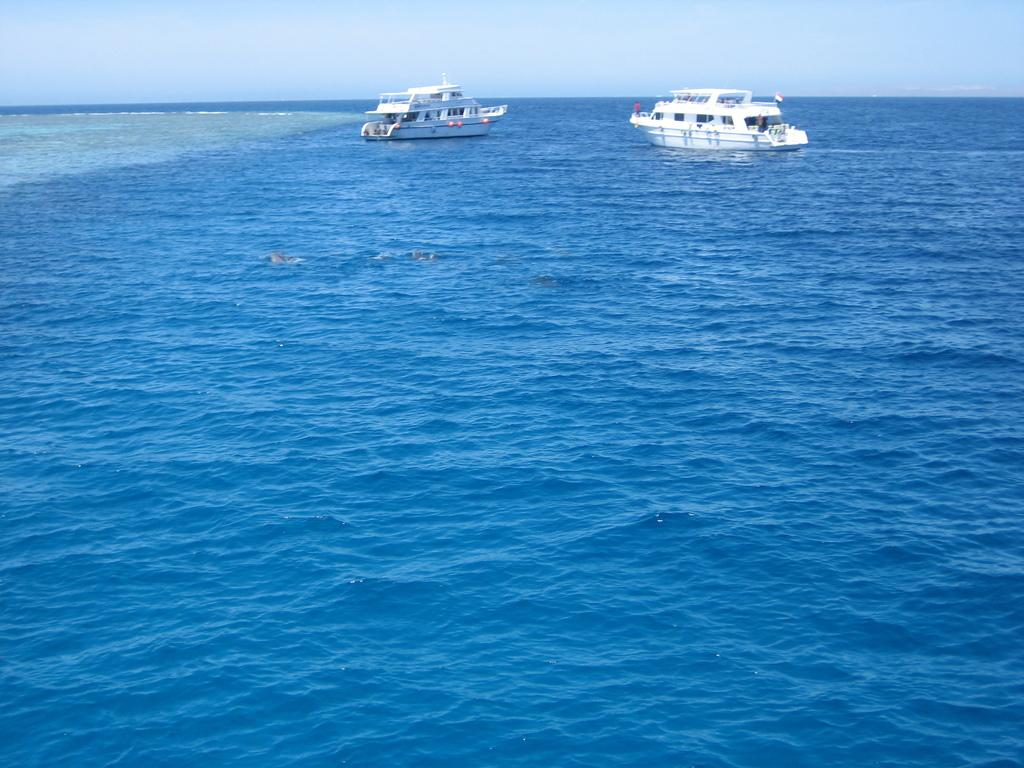What can be seen in the image? There are two ships in the image. Where are the ships located? The ships are on the water. What is visible at the top of the image? The sky is visible at the top of the image. What is visible at the bottom of the image? There is water visible at the bottom of the image. What type of magic is being performed on the ships in the image? There is no magic being performed on the ships in the image; they are simply floating on the water. 